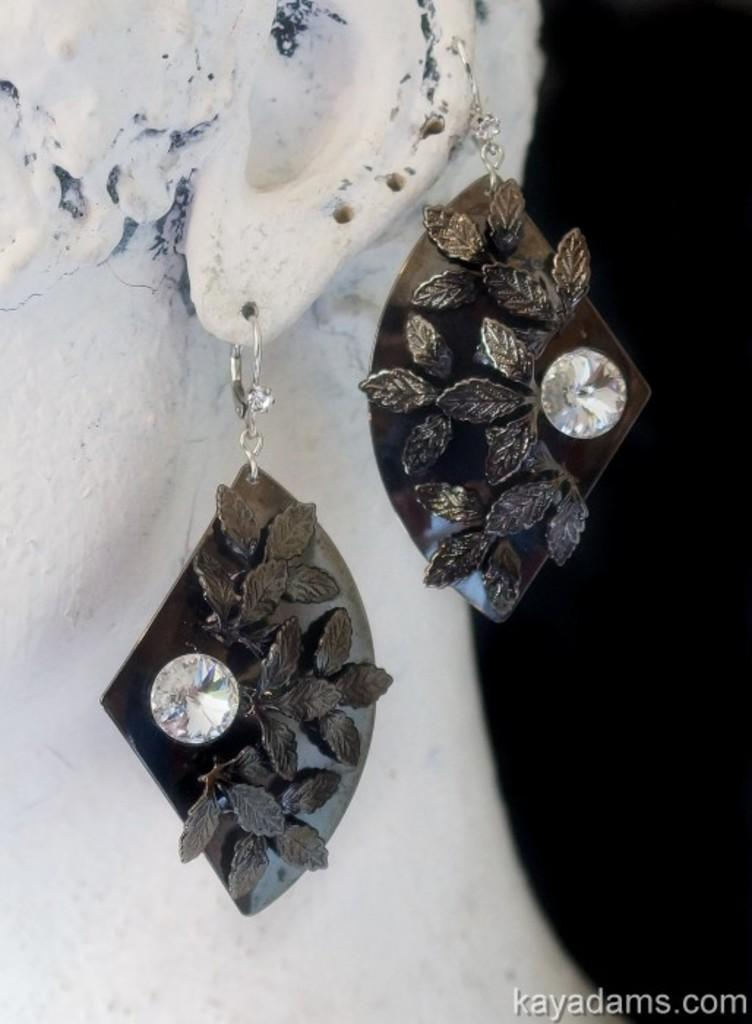What is the main subject of the image? There is a statue of a person in the image. What can be seen on the statue's ear? The statue has two earrings hanging from its ear. How would you describe the background of the image? The background of the image is dark. Is there any text present in the image? Yes, there is some text in the bottom right-hand corner of the image. Can you tell me how many teeth the statue has in the image? There is no information about the statue's teeth in the image, so it cannot be determined. 